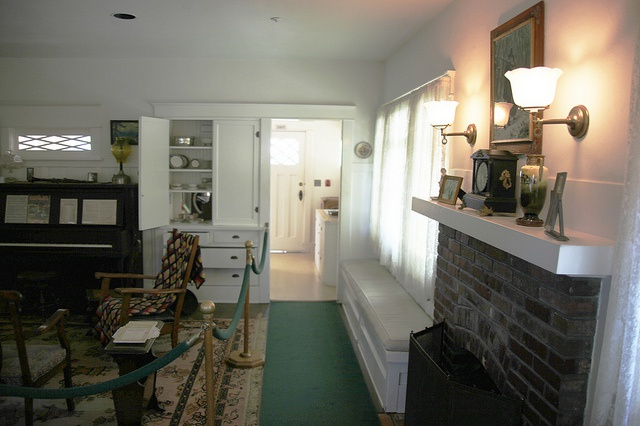Describe the objects in this image and their specific colors. I can see chair in gray, black, and maroon tones, chair in gray and black tones, vase in gray, black, and olive tones, book in gray tones, and clock in gray, black, and darkgreen tones in this image. 